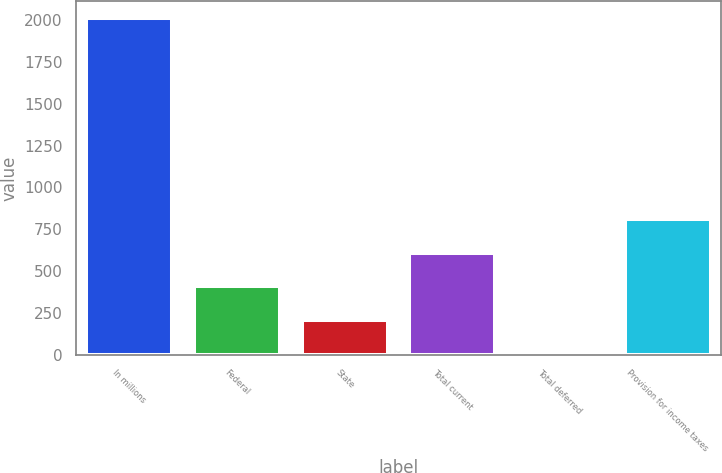Convert chart. <chart><loc_0><loc_0><loc_500><loc_500><bar_chart><fcel>In millions<fcel>Federal<fcel>State<fcel>Total current<fcel>Total deferred<fcel>Provision for income taxes<nl><fcel>2012<fcel>411.76<fcel>211.73<fcel>611.79<fcel>11.7<fcel>811.82<nl></chart> 